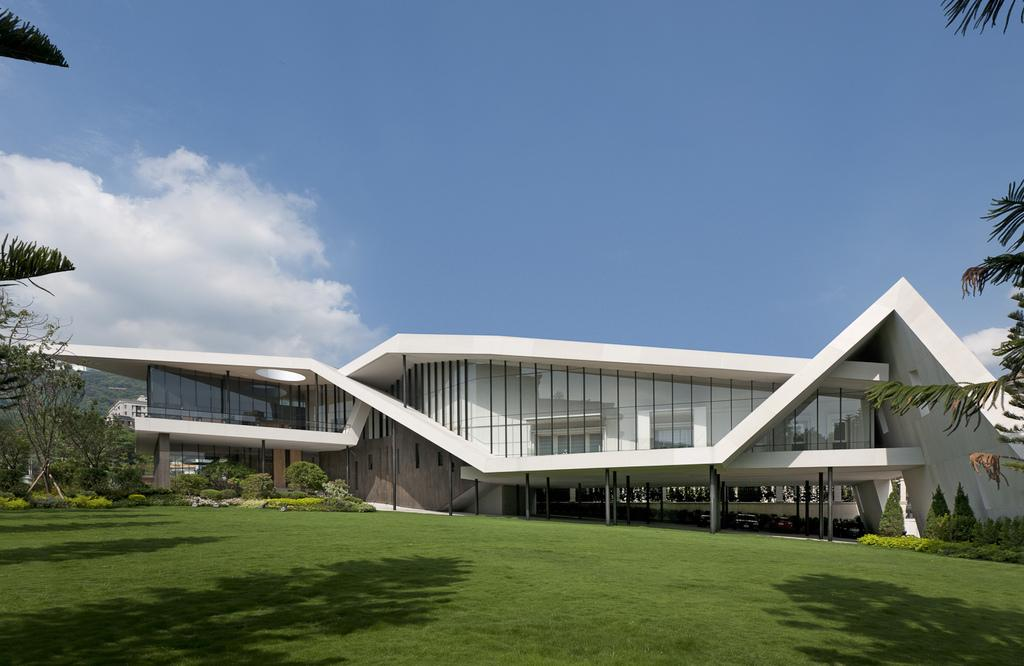What type of outdoor space is depicted in the image? There is a garden in the image. What can be found within the garden? Trees are present in the garden. What is visible in the background of the image? There is a building in the background of the image. What color is the sky in the image? The sky is blue in the image. How many apples are hanging from the trees in the image? There are no apples visible in the image; only trees are present in the garden. 